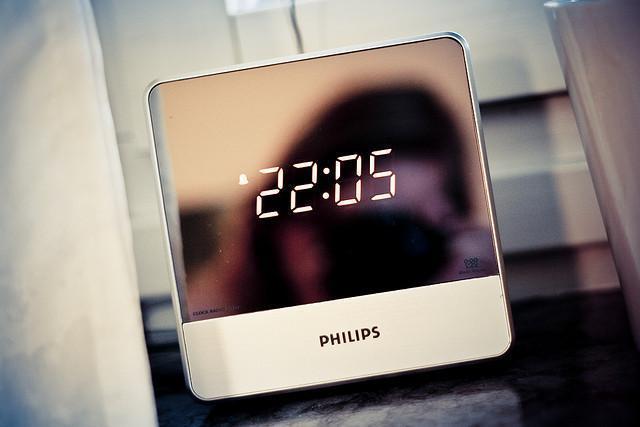How many dogs are there?
Give a very brief answer. 0. 